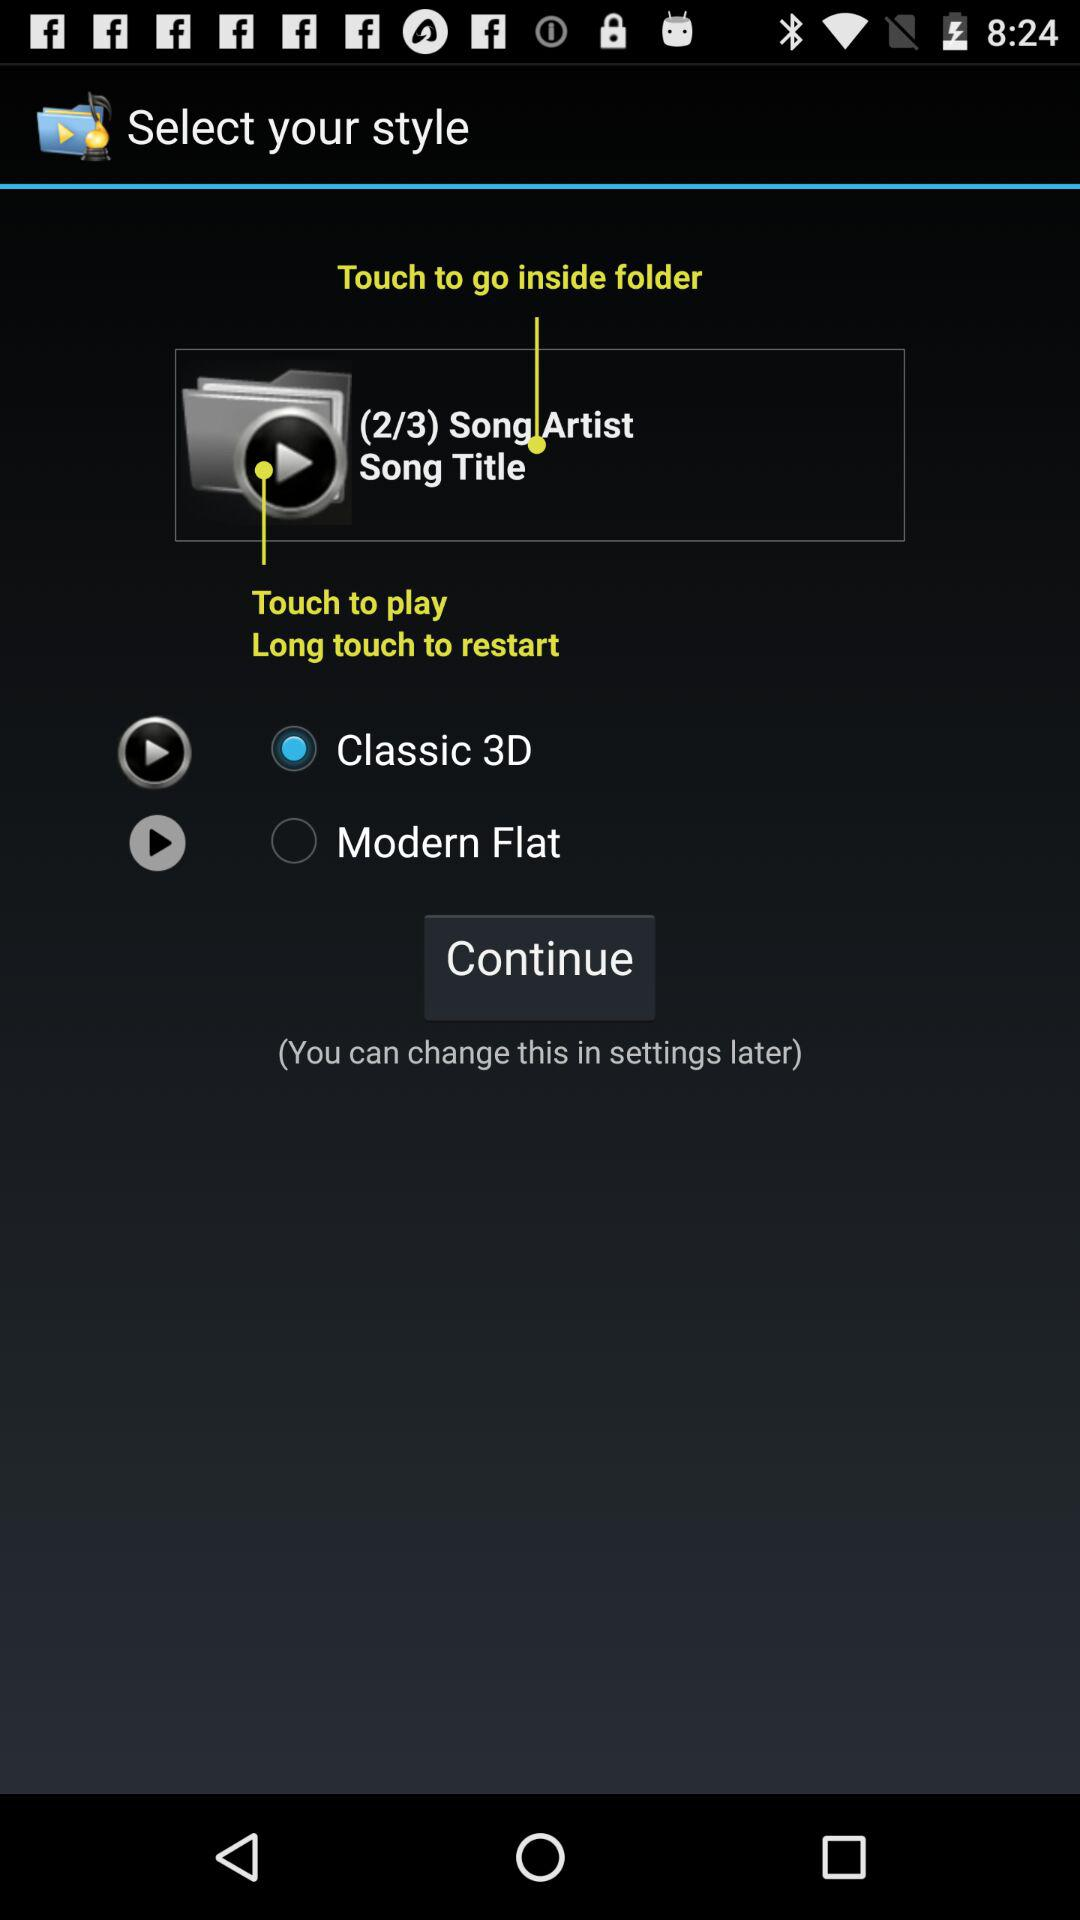Which option is selected? The selected option is "Classic 3D". 